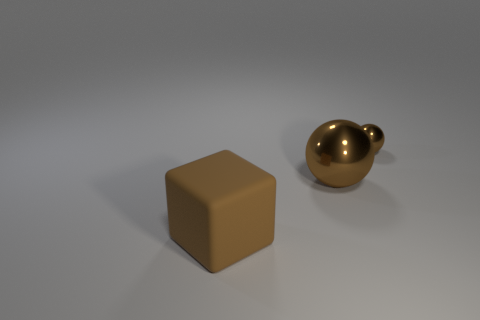Add 1 large matte cubes. How many objects exist? 4 Subtract all balls. How many objects are left? 1 Add 3 large blocks. How many large blocks exist? 4 Subtract 0 red spheres. How many objects are left? 3 Subtract all metal things. Subtract all tiny blue metal spheres. How many objects are left? 1 Add 2 brown metallic spheres. How many brown metallic spheres are left? 4 